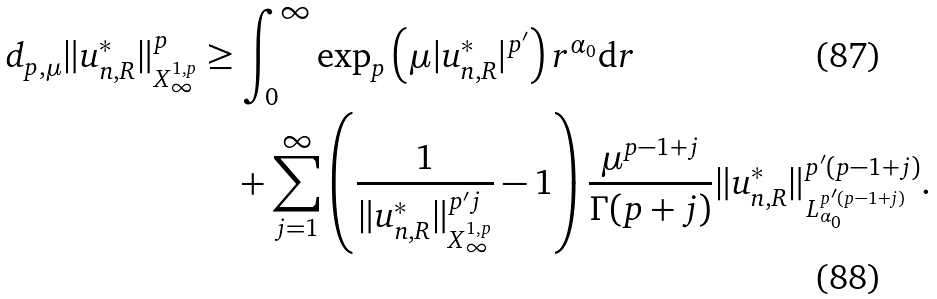<formula> <loc_0><loc_0><loc_500><loc_500>d _ { p , \mu } \| u _ { n , R } ^ { * } \| ^ { p } _ { X ^ { 1 , p } _ { \infty } } & \geq \int _ { 0 } ^ { \infty } \exp _ { p } \left ( \mu | u _ { n , R } ^ { * } | ^ { p ^ { \prime } } \right ) r ^ { \alpha _ { 0 } } \mathrm d r \\ & \quad + \sum _ { j = 1 } ^ { \infty } \left ( \frac { 1 } { \| u ^ { * } _ { n , R } \| ^ { p ^ { \prime } j } _ { X ^ { 1 , p } _ { \infty } } } - 1 \right ) \frac { \mu ^ { p - 1 + j } } { \Gamma ( p + j ) } \| u _ { n , R } ^ { * } \| ^ { p ^ { \prime } ( p - 1 + j ) } _ { L _ { \alpha _ { 0 } } ^ { p ^ { \prime } ( p - 1 + j ) } } .</formula> 